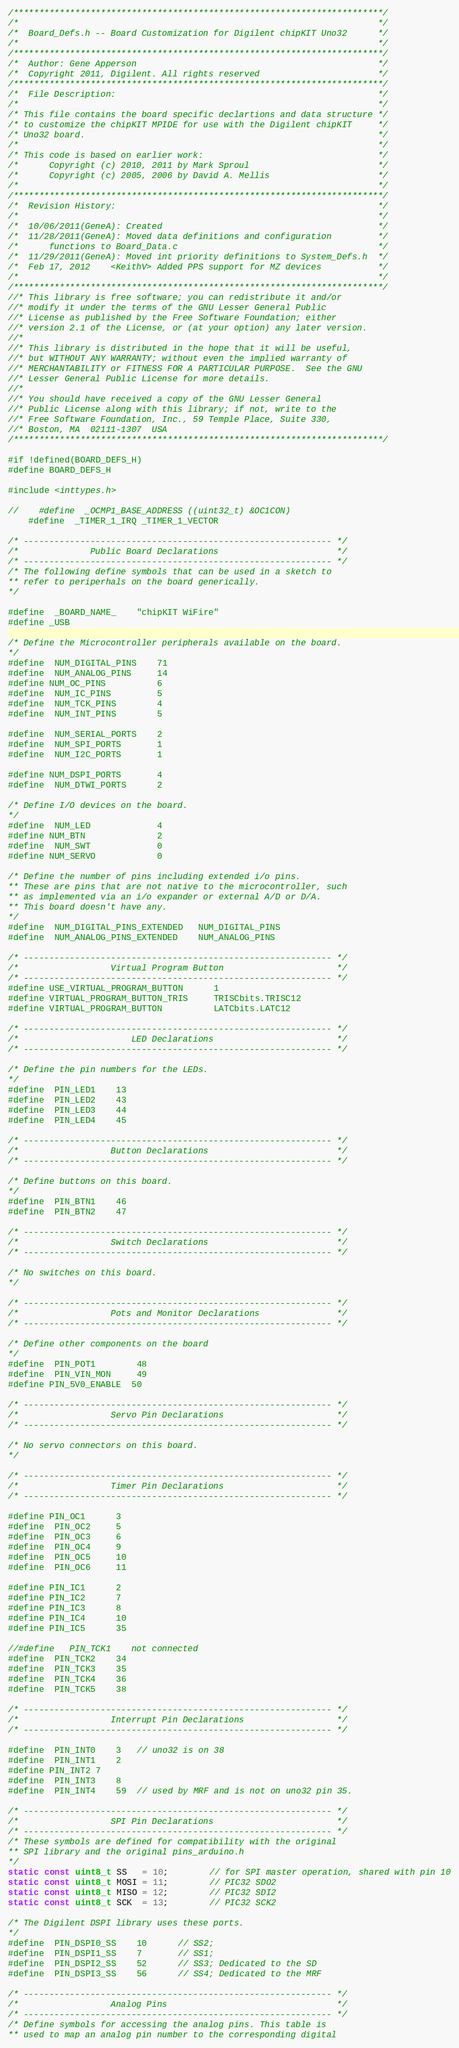Convert code to text. <code><loc_0><loc_0><loc_500><loc_500><_C_>/************************************************************************/
/*																		*/
/*	Board_Defs.h --	Board Customization for Digilent chipKIT Uno32		*/
/*																		*/
/************************************************************************/
/*	Author: Gene Apperson												*/
/*	Copyright 2011, Digilent. All rights reserved						*/
/************************************************************************/
/*  File Description:													*/
/*																		*/
/* This file contains the board specific declartions and data structure	*/
/* to customize the chipKIT MPIDE for use with the Digilent chipKIT		*/
/* Uno32 board.															*/
/*																		*/
/* This code is based on earlier work:									*/
/*		Copyright (c) 2010, 2011 by Mark Sproul							*/
/*		Copyright (c) 2005, 2006 by David A. Mellis						*/
/*																		*/
/************************************************************************/
/*  Revision History:													*/
/*																		*/
/*	10/06/2011(GeneA): Created											*/
/*	11/28/2011(GeneA): Moved data definitions and configuration			*/
/*		functions to Board_Data.c										*/
/*	11/29/2011(GeneA): Moved int priority definitions to System_Defs.h	*/
/*	Feb 17, 2012	<KeithV> Added PPS support for MZ devices           */
/*																		*/
/************************************************************************/
//*	This library is free software; you can redistribute it and/or
//*	modify it under the terms of the GNU Lesser General Public
//*	License as published by the Free Software Foundation; either
//*	version 2.1 of the License, or (at your option) any later version.
//*	
//*	This library is distributed in the hope that it will be useful,
//*	but WITHOUT ANY WARRANTY; without even the implied warranty of
//*	MERCHANTABILITY or FITNESS FOR A PARTICULAR PURPOSE.  See the GNU
//*	Lesser General Public License for more details.
//*	
//*	You should have received a copy of the GNU Lesser General
//*	Public License along with this library; if not, write to the
//*	Free Software Foundation, Inc., 59 Temple Place, Suite 330,
//*	Boston, MA  02111-1307  USA
/************************************************************************/

#if !defined(BOARD_DEFS_H)
#define BOARD_DEFS_H

#include <inttypes.h>

//    #define  _OCMP1_BASE_ADDRESS ((uint32_t) &OC1CON)
    #define  _TIMER_1_IRQ _TIMER_1_VECTOR

/* ------------------------------------------------------------ */
/*				Public Board Declarations						*/
/* ------------------------------------------------------------ */
/* The following define symbols that can be used in a sketch to
** refer to periperhals on the board generically.
*/

#define	_BOARD_NAME_	"chipKIT WiFire"
#define _USB

/* Define the Microcontroller peripherals available on the board.
*/
#define	NUM_DIGITAL_PINS	71
#define	NUM_ANALOG_PINS		14
#define NUM_OC_PINS			6
#define	NUM_IC_PINS			5
#define	NUM_TCK_PINS		4
#define	NUM_INT_PINS		5

#define	NUM_SERIAL_PORTS	2   
#define	NUM_SPI_PORTS		1   
#define	NUM_I2C_PORTS		1   

#define NUM_DSPI_PORTS		4
#define	NUM_DTWI_PORTS		2

/* Define I/O devices on the board.
*/
#define	NUM_LED				4
#define NUM_BTN				2
#define	NUM_SWT				0
#define NUM_SERVO			0

/* Define the number of pins including extended i/o pins.
** These are pins that are not native to the microcontroller, such
** as implemented via an i/o expander or external A/D or D/A.
** This board doesn't have any.
*/
#define	NUM_DIGITAL_PINS_EXTENDED	NUM_DIGITAL_PINS
#define	NUM_ANALOG_PINS_EXTENDED	NUM_ANALOG_PINS

/* ------------------------------------------------------------ */
/*					Virtual Program Button						*/
/* ------------------------------------------------------------ */
#define USE_VIRTUAL_PROGRAM_BUTTON      1
#define VIRTUAL_PROGRAM_BUTTON_TRIS     TRISCbits.TRISC12
#define VIRTUAL_PROGRAM_BUTTON          LATCbits.LATC12

/* ------------------------------------------------------------ */
/*						LED Declarations						*/
/* ------------------------------------------------------------ */

/* Define the pin numbers for the LEDs.
*/
#define	PIN_LED1	13
#define	PIN_LED2	43
#define	PIN_LED3	44
#define	PIN_LED4	45

/* ------------------------------------------------------------ */
/*					Button Declarations							*/
/* ------------------------------------------------------------ */

/* Define buttons on this board.
*/
#define	PIN_BTN1	46	
#define	PIN_BTN2	47

/* ------------------------------------------------------------ */
/*					Switch Declarations							*/
/* ------------------------------------------------------------ */

/* No switches on this board.
*/

/* ------------------------------------------------------------ */
/*					Pots and Monitor Declarations   			*/
/* ------------------------------------------------------------ */

/* Define other components on the board
*/
#define	PIN_POT1        48	
#define	PIN_VIN_MON     49
#define PIN_5V0_ENABLE  50

/* ------------------------------------------------------------ */
/*					Servo Pin Declarations						*/
/* ------------------------------------------------------------ */

/* No servo connectors on this board.
*/

/* ------------------------------------------------------------ */
/*					Timer Pin Declarations						*/
/* ------------------------------------------------------------ */

#define PIN_OC1		3
#define	PIN_OC2		5
#define	PIN_OC3		6
#define	PIN_OC4		9
#define	PIN_OC5		10
#define	PIN_OC6		11

#define PIN_IC1		2      
#define PIN_IC2		7      
#define PIN_IC3		8      
#define PIN_IC4		10
#define PIN_IC5		35

//#define	PIN_TCK1	not connected
#define	PIN_TCK2	34      
#define	PIN_TCK3	35      
#define	PIN_TCK4	36      
#define	PIN_TCK5	38

/* ------------------------------------------------------------ */
/*					Interrupt Pin Declarations					*/
/* ------------------------------------------------------------ */

#define	PIN_INT0	3   // uno32 is on 38
#define	PIN_INT1	2
#define PIN_INT2	7
#define	PIN_INT3	8
#define	PIN_INT4	59  // used by MRF and is not on uno32 pin 35.

/* ------------------------------------------------------------ */
/*					SPI Pin Declarations						*/
/* ------------------------------------------------------------ */
/* These symbols are defined for compatibility with the original
** SPI library and the original pins_arduino.h
*/
static const uint8_t SS   = 10;		// for SPI master operation, shared with pin 10
static const uint8_t MOSI = 11;		// PIC32 SDO2
static const uint8_t MISO = 12;		// PIC32 SDI2
static const uint8_t SCK  = 13;		// PIC32 SCK2

/* The Digilent DSPI library uses these ports.
*/
#define	PIN_DSPI0_SS	10      // SS2; 
#define	PIN_DSPI1_SS	7       // SS1; 
#define	PIN_DSPI2_SS	52      // SS3; Dedicated to the SD
#define	PIN_DSPI3_SS	56      // SS4; Dedicated to the MRF

/* ------------------------------------------------------------ */
/*					Analog Pins									*/
/* ------------------------------------------------------------ */
/* Define symbols for accessing the analog pins. This table is
** used to map an analog pin number to the corresponding digital</code> 